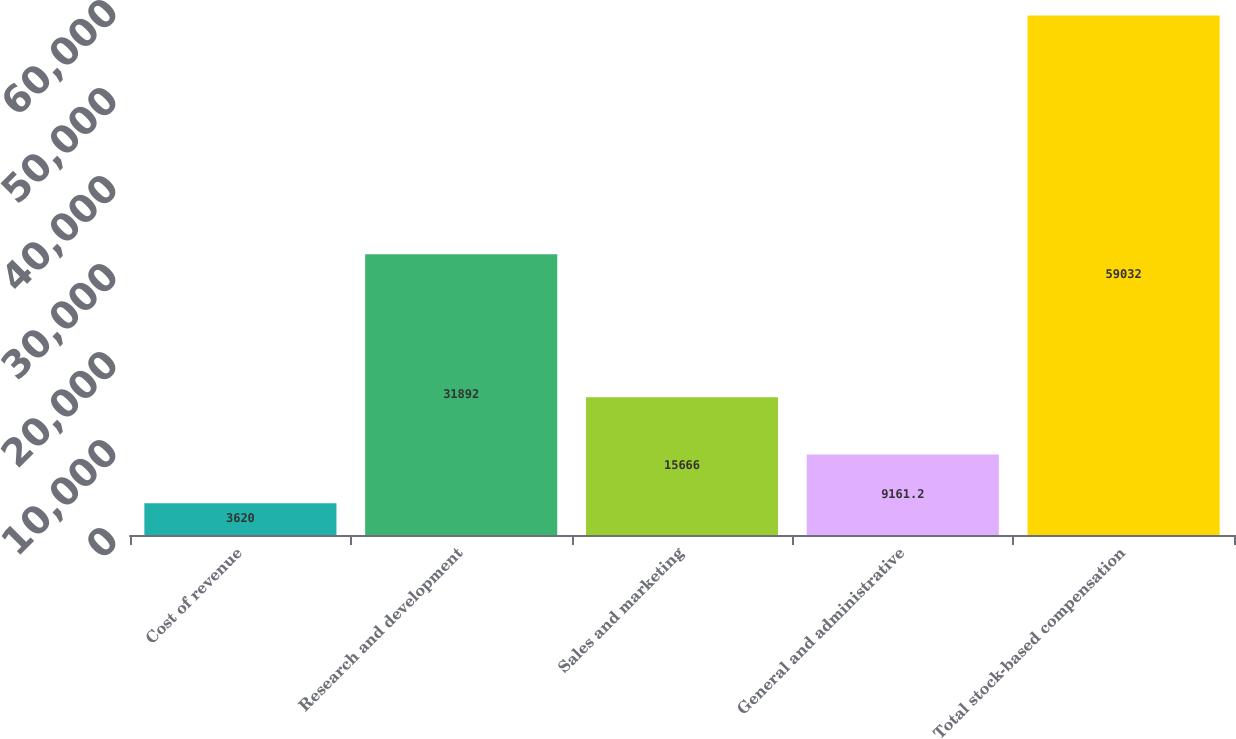Convert chart. <chart><loc_0><loc_0><loc_500><loc_500><bar_chart><fcel>Cost of revenue<fcel>Research and development<fcel>Sales and marketing<fcel>General and administrative<fcel>Total stock-based compensation<nl><fcel>3620<fcel>31892<fcel>15666<fcel>9161.2<fcel>59032<nl></chart> 